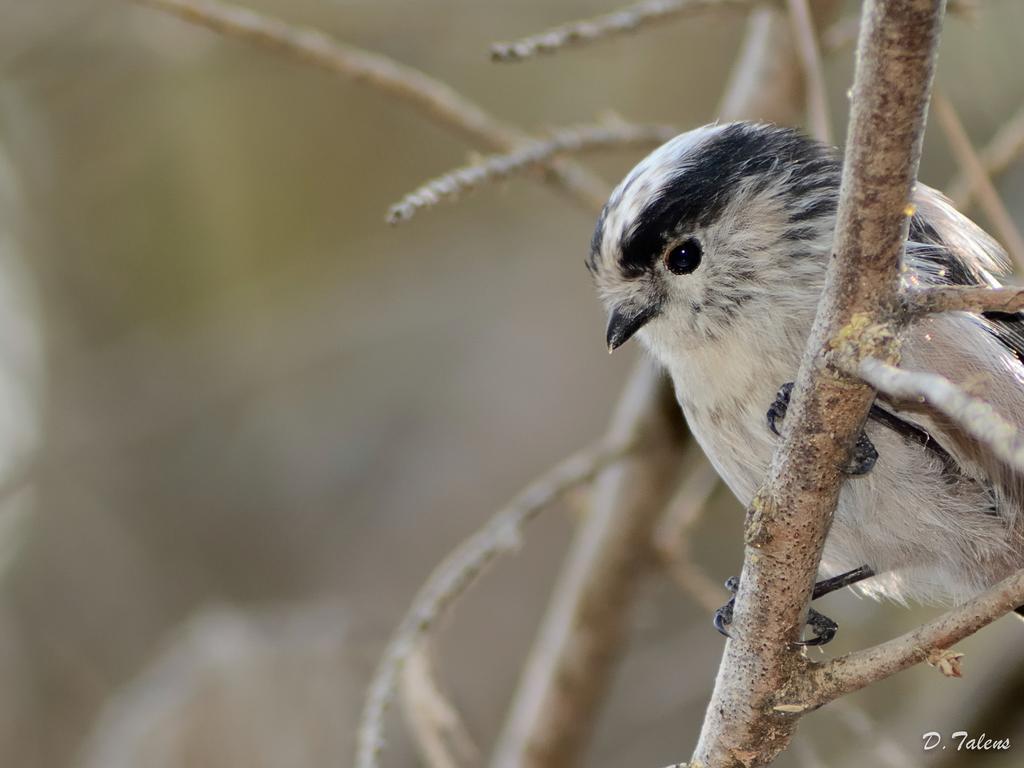Please provide a concise description of this image. In the picture we can see a small bird which is standing on the stem with twigs and the bird is white and some black shades to it. 